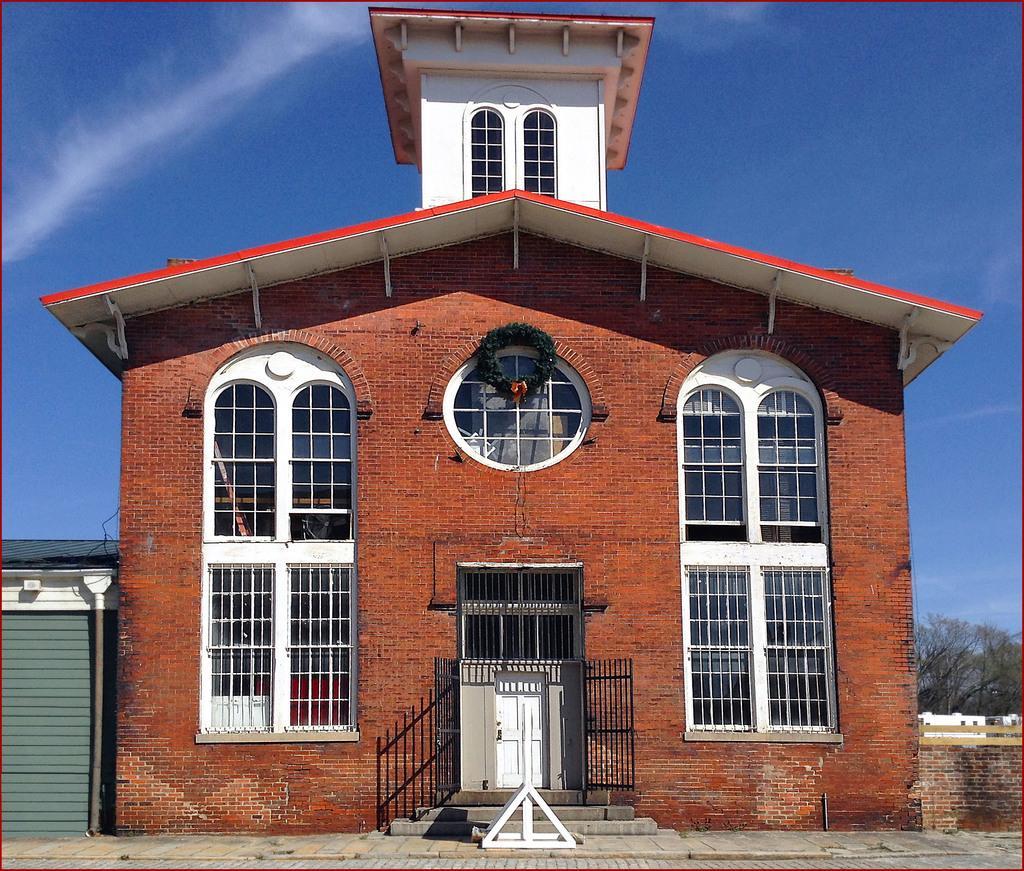Please provide a concise description of this image. In this image we can see a building with windows, grill, gate, staircase and a wreath hanged on a window. On the left side of the image we can see a pipe. In the background, we can see a group of trees and the sky. 